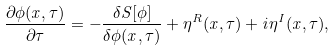<formula> <loc_0><loc_0><loc_500><loc_500>\frac { \partial \phi ( x , \tau ) } { \partial \tau } = - \frac { \delta S [ \phi ] } { \delta \phi ( x , \tau ) } + \eta ^ { R } ( x , \tau ) + i \eta ^ { I } ( x , \tau ) ,</formula> 